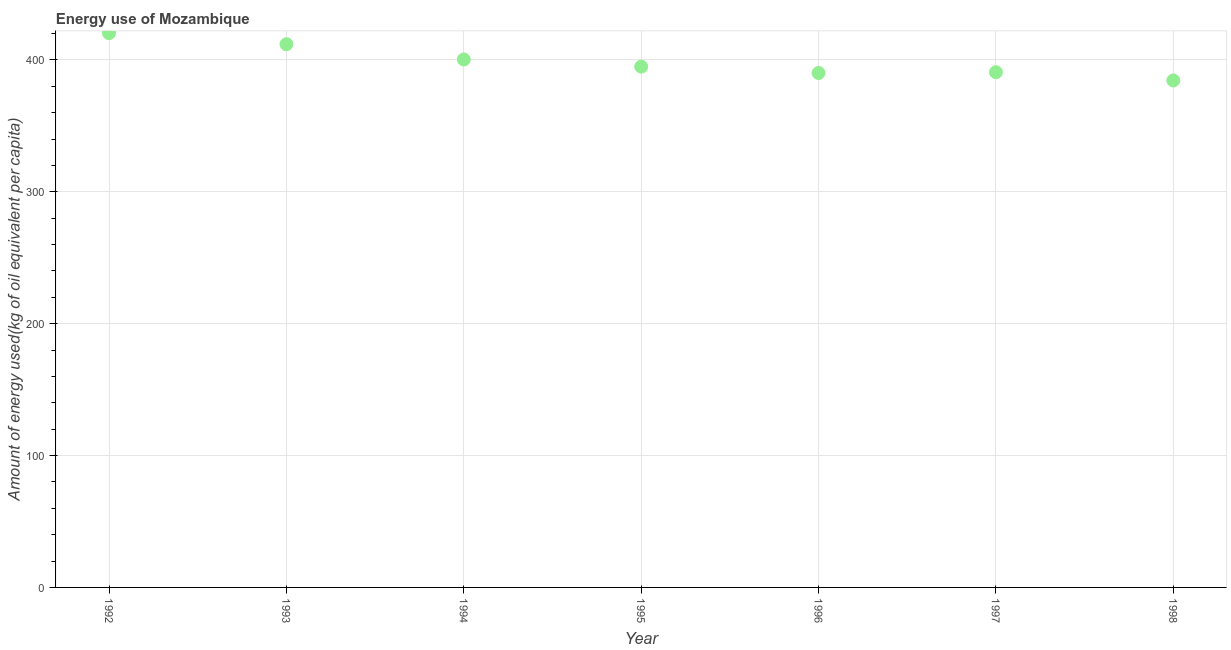What is the amount of energy used in 1992?
Offer a very short reply. 420.27. Across all years, what is the maximum amount of energy used?
Your response must be concise. 420.27. Across all years, what is the minimum amount of energy used?
Provide a succinct answer. 384.44. In which year was the amount of energy used maximum?
Provide a succinct answer. 1992. What is the sum of the amount of energy used?
Your answer should be very brief. 2792.66. What is the difference between the amount of energy used in 1997 and 1998?
Offer a very short reply. 6.25. What is the average amount of energy used per year?
Ensure brevity in your answer.  398.95. What is the median amount of energy used?
Your answer should be very brief. 394.91. In how many years, is the amount of energy used greater than 220 kg?
Your answer should be very brief. 7. Do a majority of the years between 1997 and 1993 (inclusive) have amount of energy used greater than 180 kg?
Your answer should be very brief. Yes. What is the ratio of the amount of energy used in 1993 to that in 1997?
Give a very brief answer. 1.05. Is the amount of energy used in 1994 less than that in 1995?
Your response must be concise. No. Is the difference between the amount of energy used in 1992 and 1998 greater than the difference between any two years?
Ensure brevity in your answer.  Yes. What is the difference between the highest and the second highest amount of energy used?
Provide a succinct answer. 8.35. What is the difference between the highest and the lowest amount of energy used?
Your answer should be compact. 35.83. In how many years, is the amount of energy used greater than the average amount of energy used taken over all years?
Your answer should be very brief. 3. How many years are there in the graph?
Keep it short and to the point. 7. What is the difference between two consecutive major ticks on the Y-axis?
Give a very brief answer. 100. Are the values on the major ticks of Y-axis written in scientific E-notation?
Give a very brief answer. No. Does the graph contain grids?
Make the answer very short. Yes. What is the title of the graph?
Ensure brevity in your answer.  Energy use of Mozambique. What is the label or title of the Y-axis?
Your answer should be compact. Amount of energy used(kg of oil equivalent per capita). What is the Amount of energy used(kg of oil equivalent per capita) in 1992?
Make the answer very short. 420.27. What is the Amount of energy used(kg of oil equivalent per capita) in 1993?
Your answer should be compact. 411.92. What is the Amount of energy used(kg of oil equivalent per capita) in 1994?
Your response must be concise. 400.35. What is the Amount of energy used(kg of oil equivalent per capita) in 1995?
Offer a terse response. 394.91. What is the Amount of energy used(kg of oil equivalent per capita) in 1996?
Offer a very short reply. 390.08. What is the Amount of energy used(kg of oil equivalent per capita) in 1997?
Give a very brief answer. 390.69. What is the Amount of energy used(kg of oil equivalent per capita) in 1998?
Your answer should be compact. 384.44. What is the difference between the Amount of energy used(kg of oil equivalent per capita) in 1992 and 1993?
Provide a succinct answer. 8.35. What is the difference between the Amount of energy used(kg of oil equivalent per capita) in 1992 and 1994?
Give a very brief answer. 19.93. What is the difference between the Amount of energy used(kg of oil equivalent per capita) in 1992 and 1995?
Give a very brief answer. 25.36. What is the difference between the Amount of energy used(kg of oil equivalent per capita) in 1992 and 1996?
Provide a short and direct response. 30.19. What is the difference between the Amount of energy used(kg of oil equivalent per capita) in 1992 and 1997?
Provide a succinct answer. 29.59. What is the difference between the Amount of energy used(kg of oil equivalent per capita) in 1992 and 1998?
Provide a short and direct response. 35.83. What is the difference between the Amount of energy used(kg of oil equivalent per capita) in 1993 and 1994?
Your answer should be compact. 11.57. What is the difference between the Amount of energy used(kg of oil equivalent per capita) in 1993 and 1995?
Offer a very short reply. 17. What is the difference between the Amount of energy used(kg of oil equivalent per capita) in 1993 and 1996?
Your answer should be compact. 21.84. What is the difference between the Amount of energy used(kg of oil equivalent per capita) in 1993 and 1997?
Offer a terse response. 21.23. What is the difference between the Amount of energy used(kg of oil equivalent per capita) in 1993 and 1998?
Give a very brief answer. 27.48. What is the difference between the Amount of energy used(kg of oil equivalent per capita) in 1994 and 1995?
Make the answer very short. 5.43. What is the difference between the Amount of energy used(kg of oil equivalent per capita) in 1994 and 1996?
Make the answer very short. 10.26. What is the difference between the Amount of energy used(kg of oil equivalent per capita) in 1994 and 1997?
Make the answer very short. 9.66. What is the difference between the Amount of energy used(kg of oil equivalent per capita) in 1994 and 1998?
Offer a terse response. 15.91. What is the difference between the Amount of energy used(kg of oil equivalent per capita) in 1995 and 1996?
Provide a short and direct response. 4.83. What is the difference between the Amount of energy used(kg of oil equivalent per capita) in 1995 and 1997?
Offer a very short reply. 4.23. What is the difference between the Amount of energy used(kg of oil equivalent per capita) in 1995 and 1998?
Your answer should be very brief. 10.48. What is the difference between the Amount of energy used(kg of oil equivalent per capita) in 1996 and 1997?
Give a very brief answer. -0.6. What is the difference between the Amount of energy used(kg of oil equivalent per capita) in 1996 and 1998?
Provide a short and direct response. 5.64. What is the difference between the Amount of energy used(kg of oil equivalent per capita) in 1997 and 1998?
Your response must be concise. 6.25. What is the ratio of the Amount of energy used(kg of oil equivalent per capita) in 1992 to that in 1993?
Offer a terse response. 1.02. What is the ratio of the Amount of energy used(kg of oil equivalent per capita) in 1992 to that in 1994?
Ensure brevity in your answer.  1.05. What is the ratio of the Amount of energy used(kg of oil equivalent per capita) in 1992 to that in 1995?
Provide a short and direct response. 1.06. What is the ratio of the Amount of energy used(kg of oil equivalent per capita) in 1992 to that in 1996?
Make the answer very short. 1.08. What is the ratio of the Amount of energy used(kg of oil equivalent per capita) in 1992 to that in 1997?
Your response must be concise. 1.08. What is the ratio of the Amount of energy used(kg of oil equivalent per capita) in 1992 to that in 1998?
Offer a terse response. 1.09. What is the ratio of the Amount of energy used(kg of oil equivalent per capita) in 1993 to that in 1995?
Give a very brief answer. 1.04. What is the ratio of the Amount of energy used(kg of oil equivalent per capita) in 1993 to that in 1996?
Offer a terse response. 1.06. What is the ratio of the Amount of energy used(kg of oil equivalent per capita) in 1993 to that in 1997?
Your response must be concise. 1.05. What is the ratio of the Amount of energy used(kg of oil equivalent per capita) in 1993 to that in 1998?
Keep it short and to the point. 1.07. What is the ratio of the Amount of energy used(kg of oil equivalent per capita) in 1994 to that in 1996?
Give a very brief answer. 1.03. What is the ratio of the Amount of energy used(kg of oil equivalent per capita) in 1994 to that in 1997?
Your answer should be compact. 1.02. What is the ratio of the Amount of energy used(kg of oil equivalent per capita) in 1994 to that in 1998?
Provide a short and direct response. 1.04. What is the ratio of the Amount of energy used(kg of oil equivalent per capita) in 1995 to that in 1996?
Your answer should be very brief. 1.01. What is the ratio of the Amount of energy used(kg of oil equivalent per capita) in 1995 to that in 1998?
Your response must be concise. 1.03. What is the ratio of the Amount of energy used(kg of oil equivalent per capita) in 1996 to that in 1998?
Make the answer very short. 1.01. 